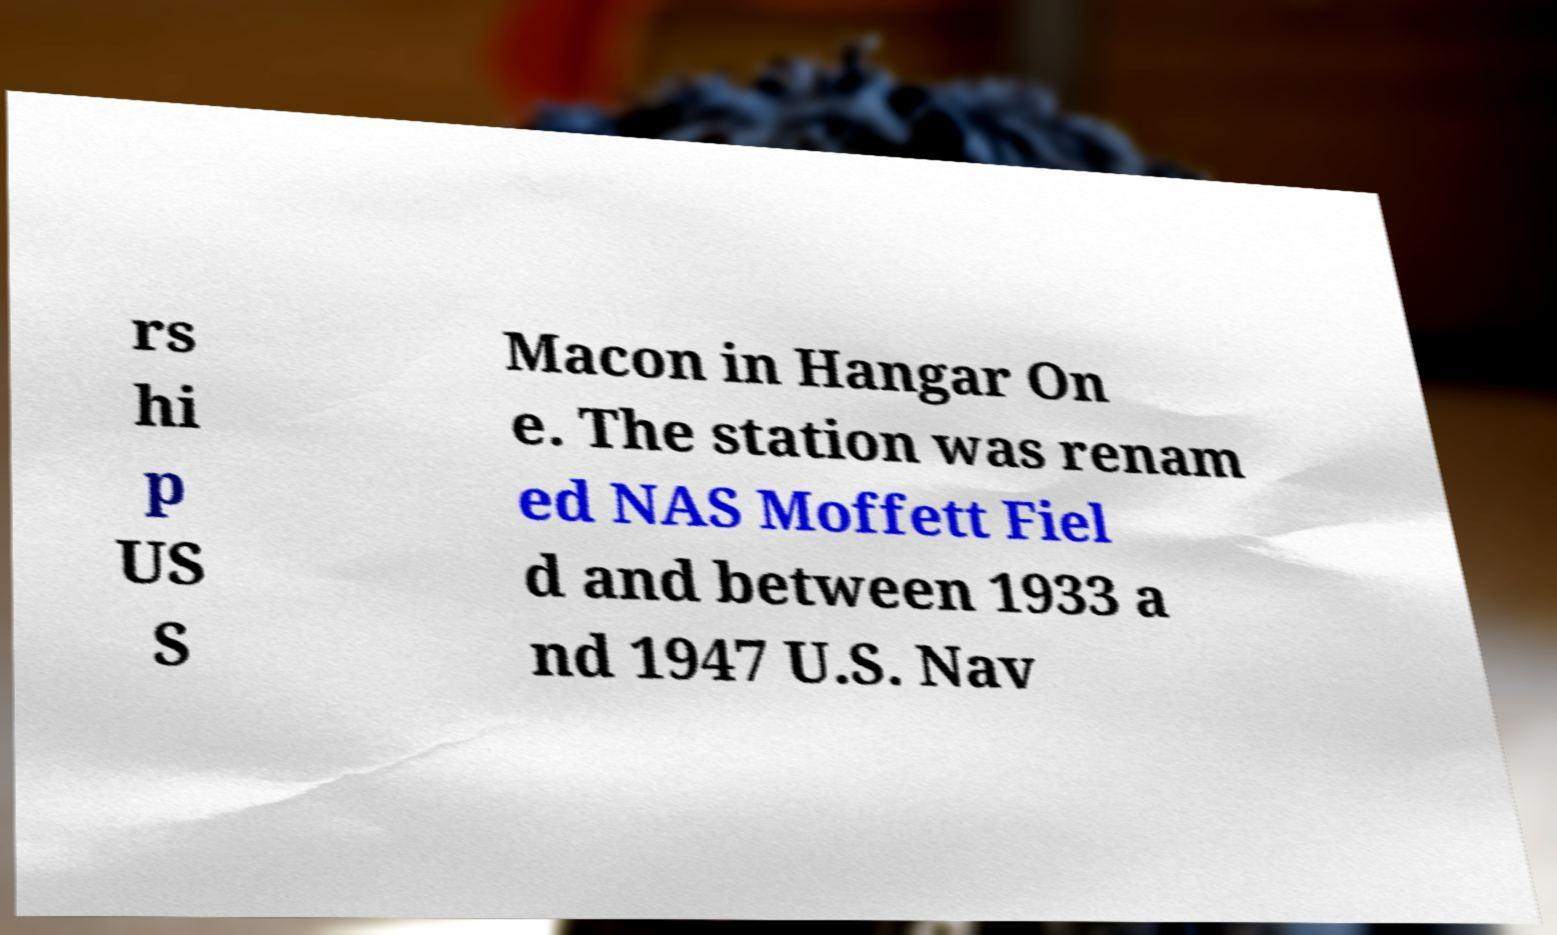Can you read and provide the text displayed in the image?This photo seems to have some interesting text. Can you extract and type it out for me? rs hi p US S Macon in Hangar On e. The station was renam ed NAS Moffett Fiel d and between 1933 a nd 1947 U.S. Nav 